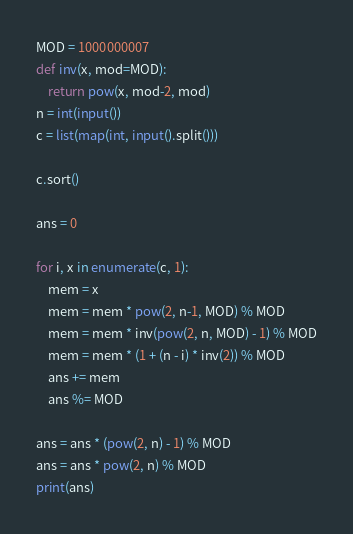<code> <loc_0><loc_0><loc_500><loc_500><_Python_>MOD = 1000000007
def inv(x, mod=MOD):
    return pow(x, mod-2, mod)
n = int(input())
c = list(map(int, input().split()))

c.sort()

ans = 0

for i, x in enumerate(c, 1):
    mem = x
    mem = mem * pow(2, n-1, MOD) % MOD
    mem = mem * inv(pow(2, n, MOD) - 1) % MOD
    mem = mem * (1 + (n - i) * inv(2)) % MOD
    ans += mem
    ans %= MOD

ans = ans * (pow(2, n) - 1) % MOD
ans = ans * pow(2, n) % MOD
print(ans)
</code> 